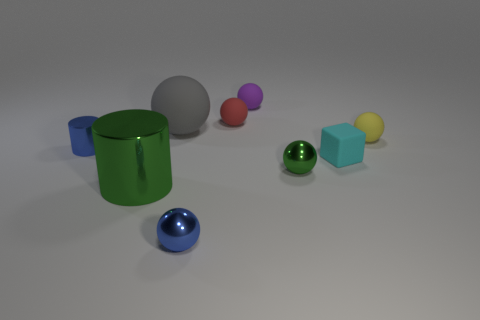What is the material of the ball that is the same color as the tiny shiny cylinder?
Provide a short and direct response. Metal. There is a tiny blue thing that is to the right of the shiny object that is behind the tiny matte block; what is its material?
Your answer should be very brief. Metal. What material is the small green thing that is the same shape as the small yellow rubber object?
Offer a terse response. Metal. Does the ball to the right of the green ball have the same size as the big metallic cylinder?
Provide a short and direct response. No. How many metal things are red cylinders or small spheres?
Offer a very short reply. 2. There is a small thing that is in front of the small blue cylinder and right of the small green shiny ball; what material is it?
Your answer should be compact. Rubber. Does the small purple object have the same material as the blue ball?
Offer a terse response. No. There is a ball that is both right of the small purple thing and to the left of the yellow rubber sphere; what size is it?
Offer a terse response. Small. What shape is the tiny purple object?
Give a very brief answer. Sphere. What number of objects are either gray spheres or tiny objects that are in front of the cyan rubber thing?
Make the answer very short. 3. 